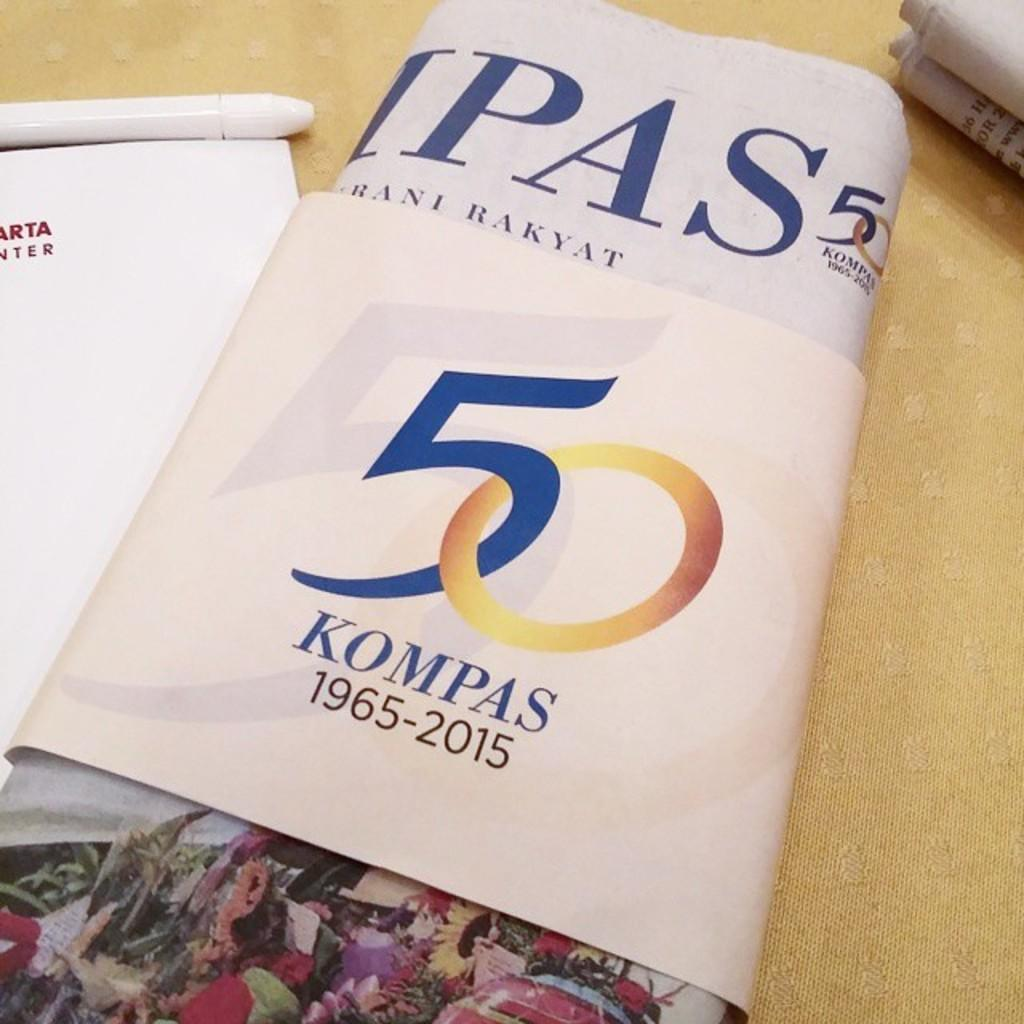<image>
Describe the image concisely. A book laying on a table where on the front of the cover states 50 Kompass 196-2015. 